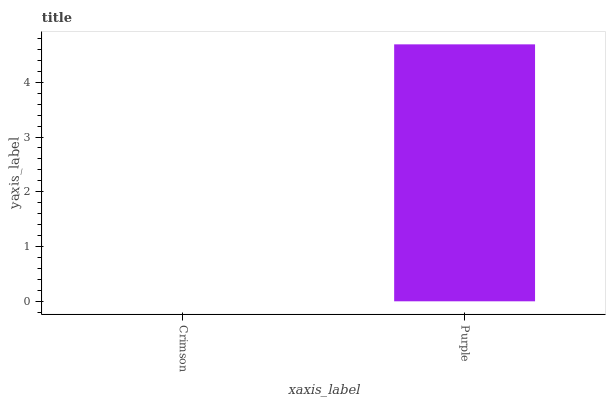Is Crimson the minimum?
Answer yes or no. Yes. Is Purple the maximum?
Answer yes or no. Yes. Is Purple the minimum?
Answer yes or no. No. Is Purple greater than Crimson?
Answer yes or no. Yes. Is Crimson less than Purple?
Answer yes or no. Yes. Is Crimson greater than Purple?
Answer yes or no. No. Is Purple less than Crimson?
Answer yes or no. No. Is Purple the high median?
Answer yes or no. Yes. Is Crimson the low median?
Answer yes or no. Yes. Is Crimson the high median?
Answer yes or no. No. Is Purple the low median?
Answer yes or no. No. 